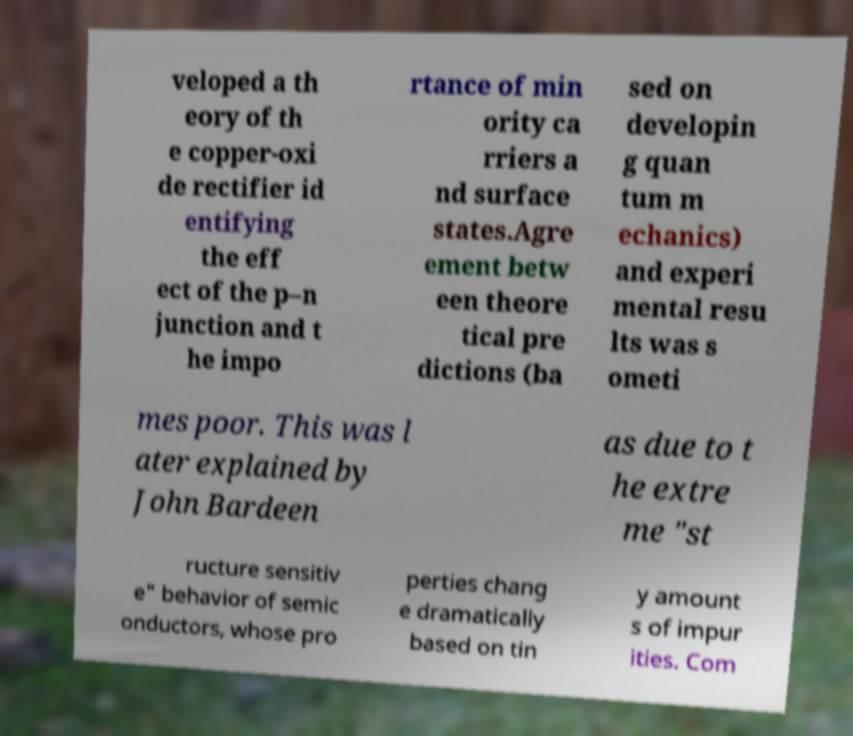Could you assist in decoding the text presented in this image and type it out clearly? veloped a th eory of th e copper-oxi de rectifier id entifying the eff ect of the p–n junction and t he impo rtance of min ority ca rriers a nd surface states.Agre ement betw een theore tical pre dictions (ba sed on developin g quan tum m echanics) and experi mental resu lts was s ometi mes poor. This was l ater explained by John Bardeen as due to t he extre me "st ructure sensitiv e" behavior of semic onductors, whose pro perties chang e dramatically based on tin y amount s of impur ities. Com 